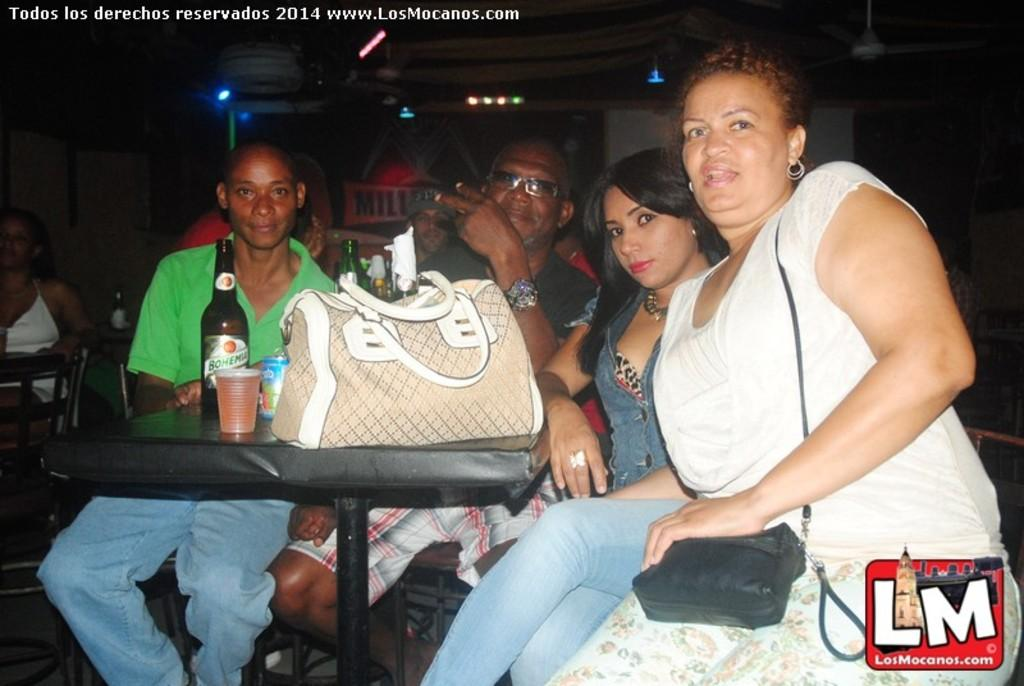What are the persons in the image doing? The persons in the image are sitting on chairs. Where are the chairs located in relation to the table? The chairs are near a table. What objects can be seen on the table? There is a bag, a bottle, and a glass on the table. What type of beef is being served in the lunchroom in the image? There is no lunchroom or beef present in the image. What kind of art can be seen hanging on the wall in the image? There is no art or wall visible in the image. 